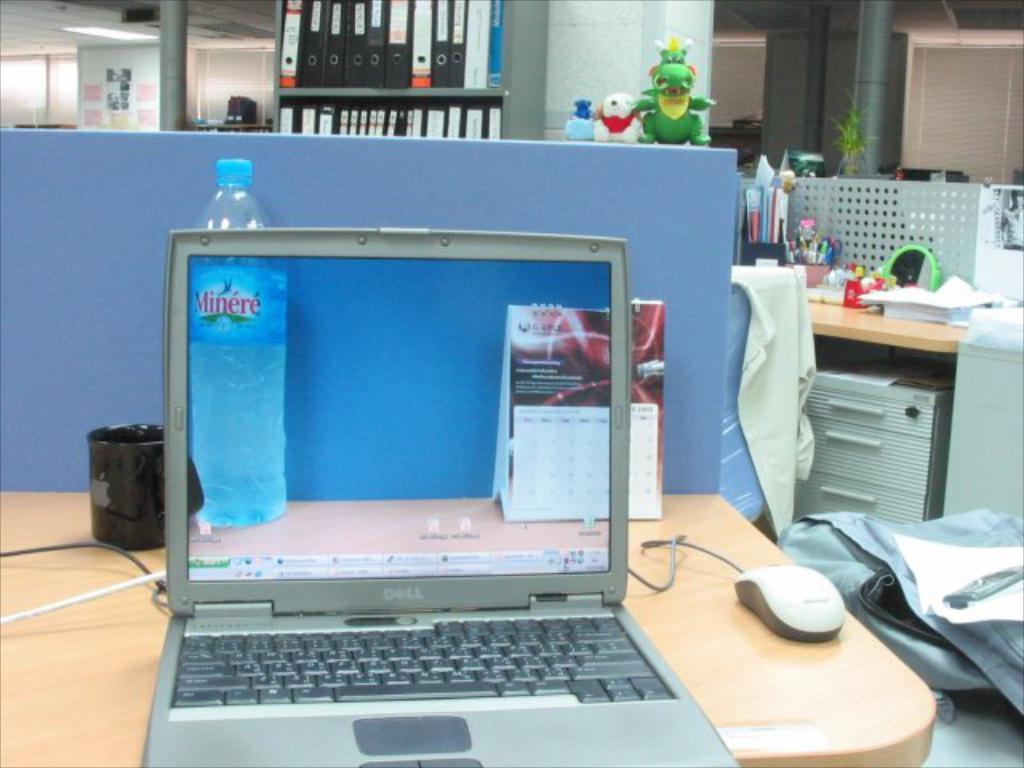What brand of laptop is this?
Provide a succinct answer. Dell. What bottle water brand is pictured?
Keep it short and to the point. Minere. 